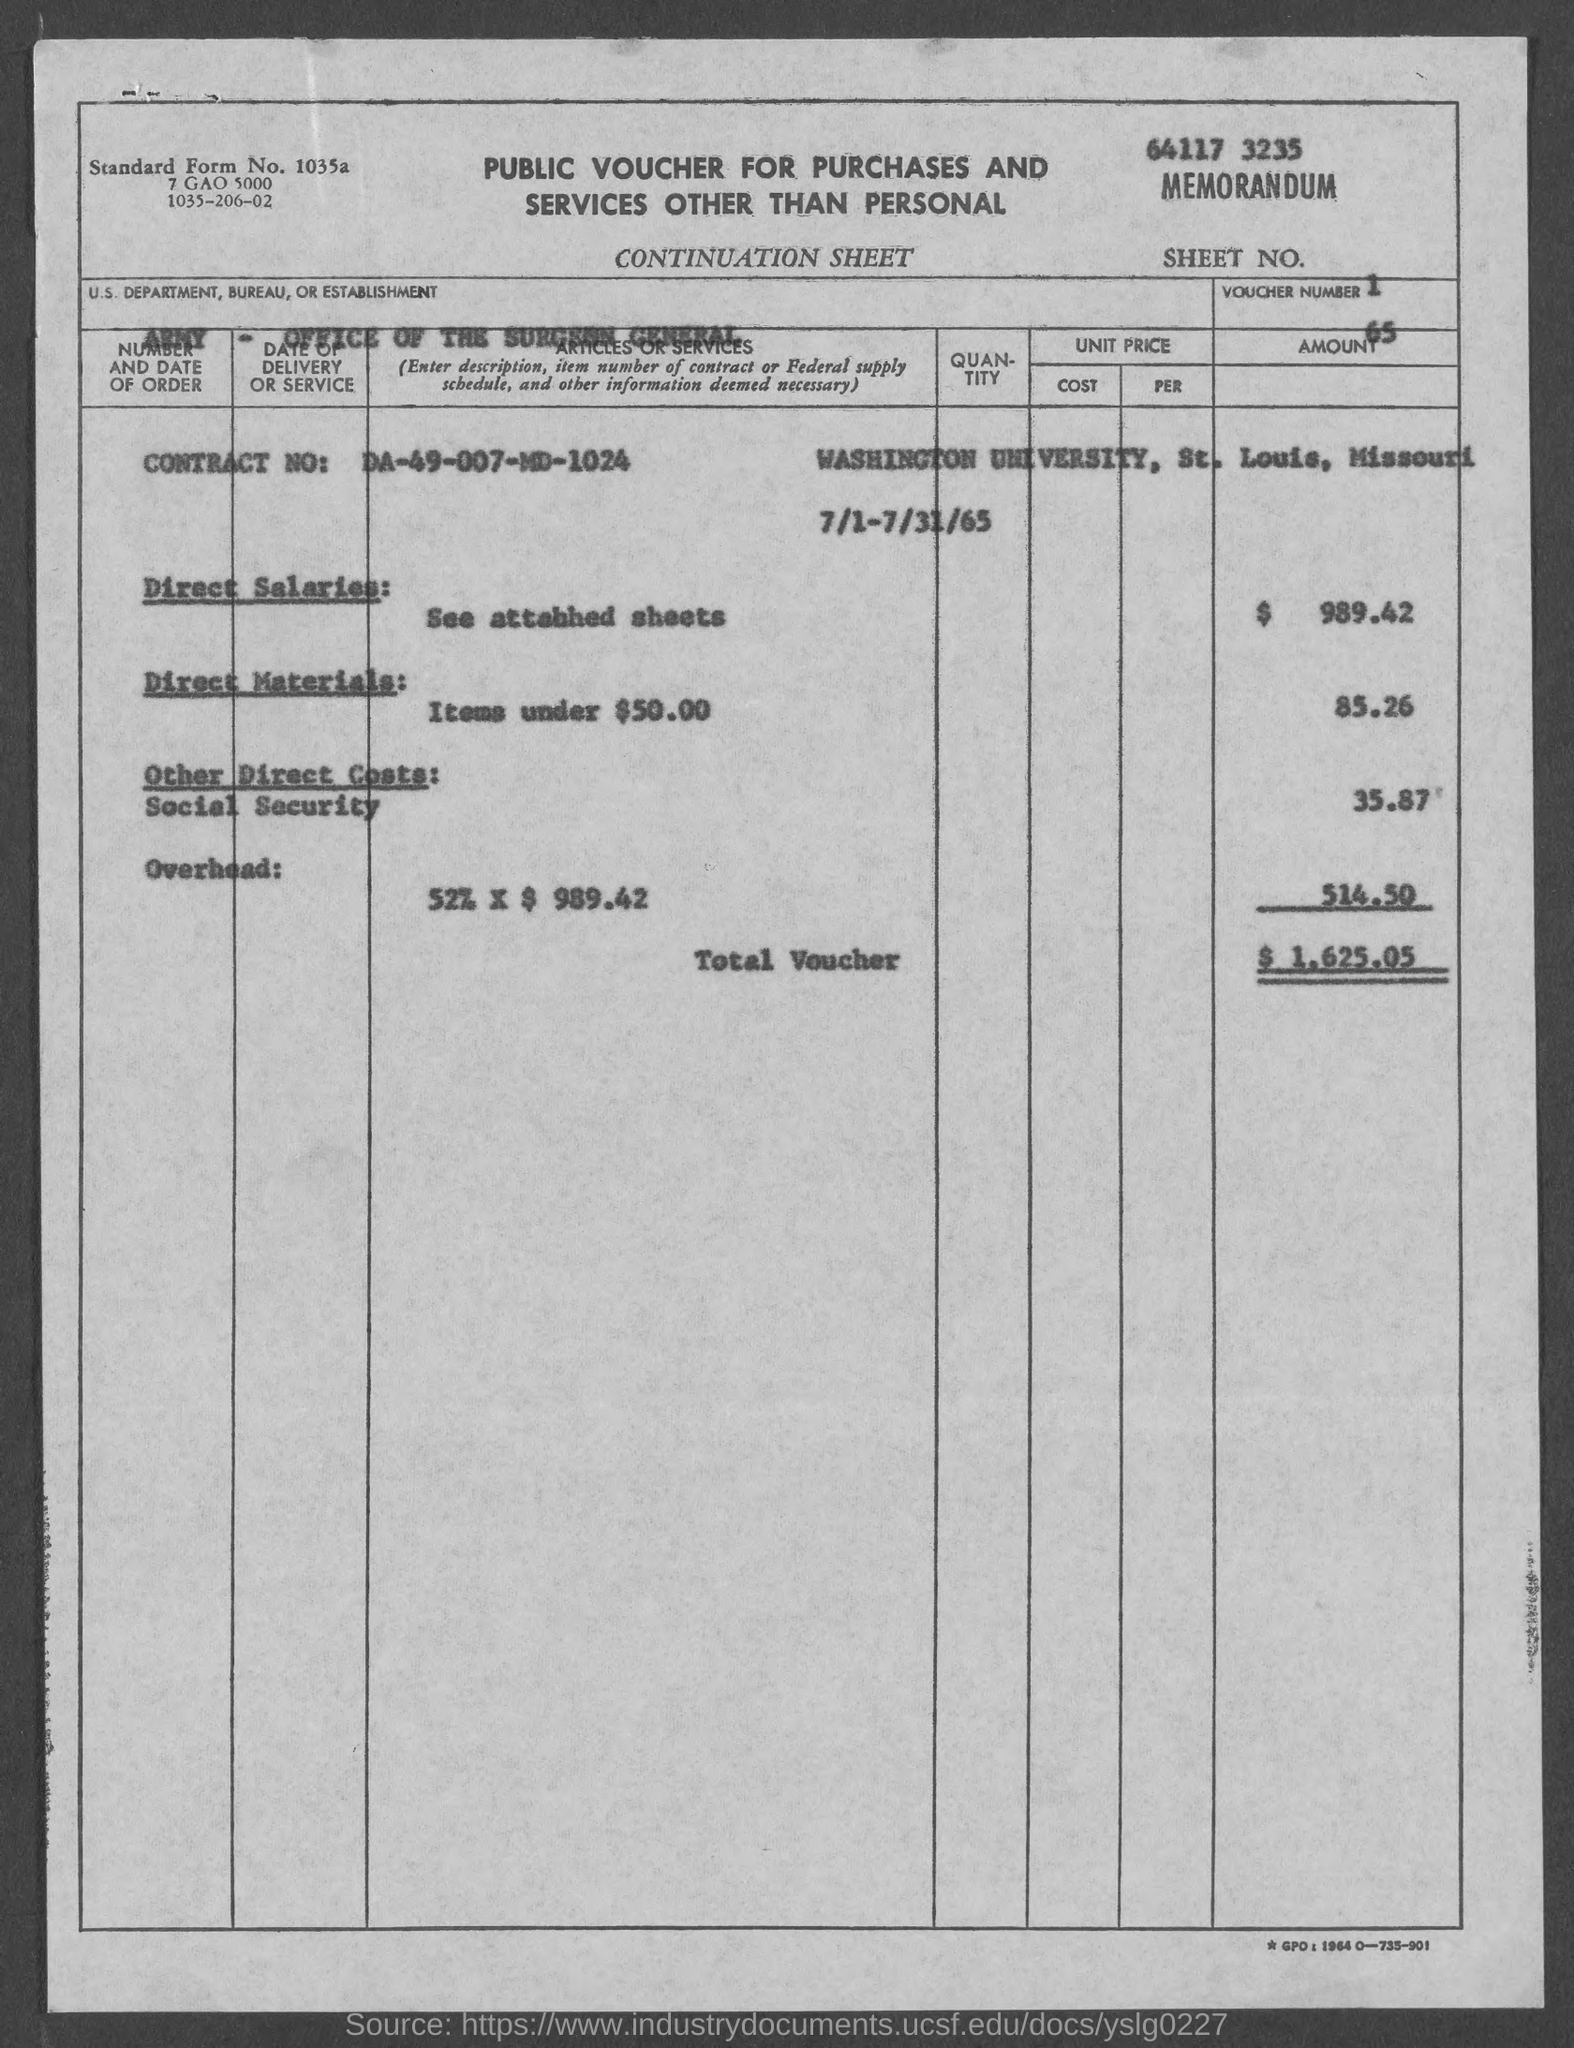Draw attention to some important aspects in this diagram. The standard form number listed in the voucher is 1035a...," was stated. The direct salaries cost mentioned in the voucher is $989.42. The sheet number mentioned in the voucher is 1. This voucher is a public voucher for purchases and services other than personal in nature. The voucher lists the U.S. Department, Bureau, or Establishment as the Army's Office of the Surgeon General. 